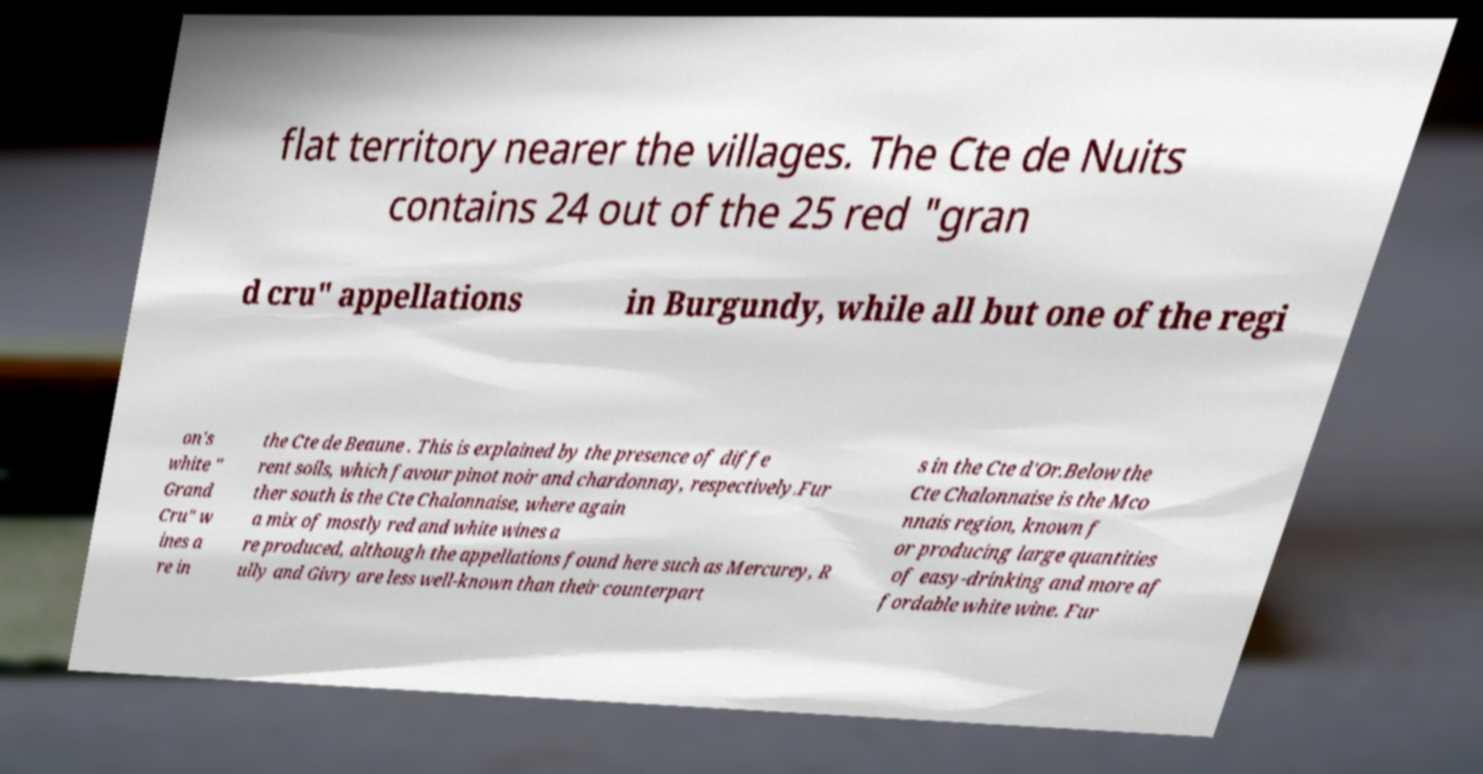Please read and relay the text visible in this image. What does it say? flat territory nearer the villages. The Cte de Nuits contains 24 out of the 25 red "gran d cru" appellations in Burgundy, while all but one of the regi on's white " Grand Cru" w ines a re in the Cte de Beaune . This is explained by the presence of diffe rent soils, which favour pinot noir and chardonnay, respectively.Fur ther south is the Cte Chalonnaise, where again a mix of mostly red and white wines a re produced, although the appellations found here such as Mercurey, R ully and Givry are less well-known than their counterpart s in the Cte d'Or.Below the Cte Chalonnaise is the Mco nnais region, known f or producing large quantities of easy-drinking and more af fordable white wine. Fur 